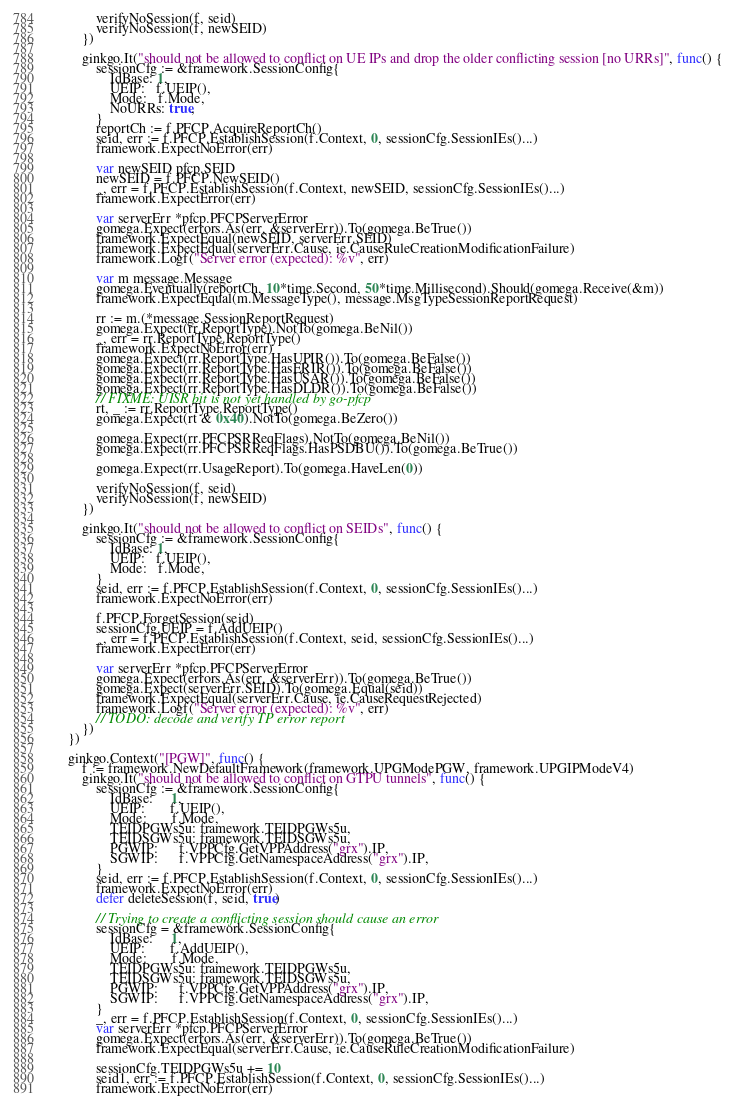<code> <loc_0><loc_0><loc_500><loc_500><_Go_>			verifyNoSession(f, seid)
			verifyNoSession(f, newSEID)
		})

		ginkgo.It("should not be allowed to conflict on UE IPs and drop the older conflicting session [no URRs]", func() {
			sessionCfg := &framework.SessionConfig{
				IdBase: 1,
				UEIP:   f.UEIP(),
				Mode:   f.Mode,
				NoURRs: true,
			}
			reportCh := f.PFCP.AcquireReportCh()
			seid, err := f.PFCP.EstablishSession(f.Context, 0, sessionCfg.SessionIEs()...)
			framework.ExpectNoError(err)

			var newSEID pfcp.SEID
			newSEID = f.PFCP.NewSEID()
			_, err = f.PFCP.EstablishSession(f.Context, newSEID, sessionCfg.SessionIEs()...)
			framework.ExpectError(err)

			var serverErr *pfcp.PFCPServerError
			gomega.Expect(errors.As(err, &serverErr)).To(gomega.BeTrue())
			framework.ExpectEqual(newSEID, serverErr.SEID)
			framework.ExpectEqual(serverErr.Cause, ie.CauseRuleCreationModificationFailure)
			framework.Logf("Server error (expected): %v", err)

			var m message.Message
			gomega.Eventually(reportCh, 10*time.Second, 50*time.Millisecond).Should(gomega.Receive(&m))
			framework.ExpectEqual(m.MessageType(), message.MsgTypeSessionReportRequest)

			rr := m.(*message.SessionReportRequest)
			gomega.Expect(rr.ReportType).NotTo(gomega.BeNil())
			_, err = rr.ReportType.ReportType()
			framework.ExpectNoError(err)
			gomega.Expect(rr.ReportType.HasUPIR()).To(gomega.BeFalse())
			gomega.Expect(rr.ReportType.HasERIR()).To(gomega.BeFalse())
			gomega.Expect(rr.ReportType.HasUSAR()).To(gomega.BeFalse())
			gomega.Expect(rr.ReportType.HasDLDR()).To(gomega.BeFalse())
			// FIXME: UISR bit is not yet handled by go-pfcp
			rt, _ := rr.ReportType.ReportType()
			gomega.Expect(rt & 0x40).NotTo(gomega.BeZero())

			gomega.Expect(rr.PFCPSRReqFlags).NotTo(gomega.BeNil())
			gomega.Expect(rr.PFCPSRReqFlags.HasPSDBU()).To(gomega.BeTrue())

			gomega.Expect(rr.UsageReport).To(gomega.HaveLen(0))

			verifyNoSession(f, seid)
			verifyNoSession(f, newSEID)
		})

		ginkgo.It("should not be allowed to conflict on SEIDs", func() {
			sessionCfg := &framework.SessionConfig{
				IdBase: 1,
				UEIP:   f.UEIP(),
				Mode:   f.Mode,
			}
			seid, err := f.PFCP.EstablishSession(f.Context, 0, sessionCfg.SessionIEs()...)
			framework.ExpectNoError(err)

			f.PFCP.ForgetSession(seid)
			sessionCfg.UEIP = f.AddUEIP()
			_, err = f.PFCP.EstablishSession(f.Context, seid, sessionCfg.SessionIEs()...)
			framework.ExpectError(err)

			var serverErr *pfcp.PFCPServerError
			gomega.Expect(errors.As(err, &serverErr)).To(gomega.BeTrue())
			gomega.Expect(serverErr.SEID).To(gomega.Equal(seid))
			framework.ExpectEqual(serverErr.Cause, ie.CauseRequestRejected)
			framework.Logf("Server error (expected): %v", err)
			// TODO: decode and verify TP error report
		})
	})

	ginkgo.Context("[PGW]", func() {
		f := framework.NewDefaultFramework(framework.UPGModePGW, framework.UPGIPModeV4)
		ginkgo.It("should not be allowed to conflict on GTPU tunnels", func() {
			sessionCfg := &framework.SessionConfig{
				IdBase:     1,
				UEIP:       f.UEIP(),
				Mode:       f.Mode,
				TEIDPGWs5u: framework.TEIDPGWs5u,
				TEIDSGWs5u: framework.TEIDSGWs5u,
				PGWIP:      f.VPPCfg.GetVPPAddress("grx").IP,
				SGWIP:      f.VPPCfg.GetNamespaceAddress("grx").IP,
			}
			seid, err := f.PFCP.EstablishSession(f.Context, 0, sessionCfg.SessionIEs()...)
			framework.ExpectNoError(err)
			defer deleteSession(f, seid, true)

			// Trying to create a conflicting session should cause an error
			sessionCfg = &framework.SessionConfig{
				IdBase:     1,
				UEIP:       f.AddUEIP(),
				Mode:       f.Mode,
				TEIDPGWs5u: framework.TEIDPGWs5u,
				TEIDSGWs5u: framework.TEIDSGWs5u,
				PGWIP:      f.VPPCfg.GetVPPAddress("grx").IP,
				SGWIP:      f.VPPCfg.GetNamespaceAddress("grx").IP,
			}
			_, err = f.PFCP.EstablishSession(f.Context, 0, sessionCfg.SessionIEs()...)
			var serverErr *pfcp.PFCPServerError
			gomega.Expect(errors.As(err, &serverErr)).To(gomega.BeTrue())
			framework.ExpectEqual(serverErr.Cause, ie.CauseRuleCreationModificationFailure)

			sessionCfg.TEIDPGWs5u += 10
			seid1, err := f.PFCP.EstablishSession(f.Context, 0, sessionCfg.SessionIEs()...)
			framework.ExpectNoError(err)</code> 